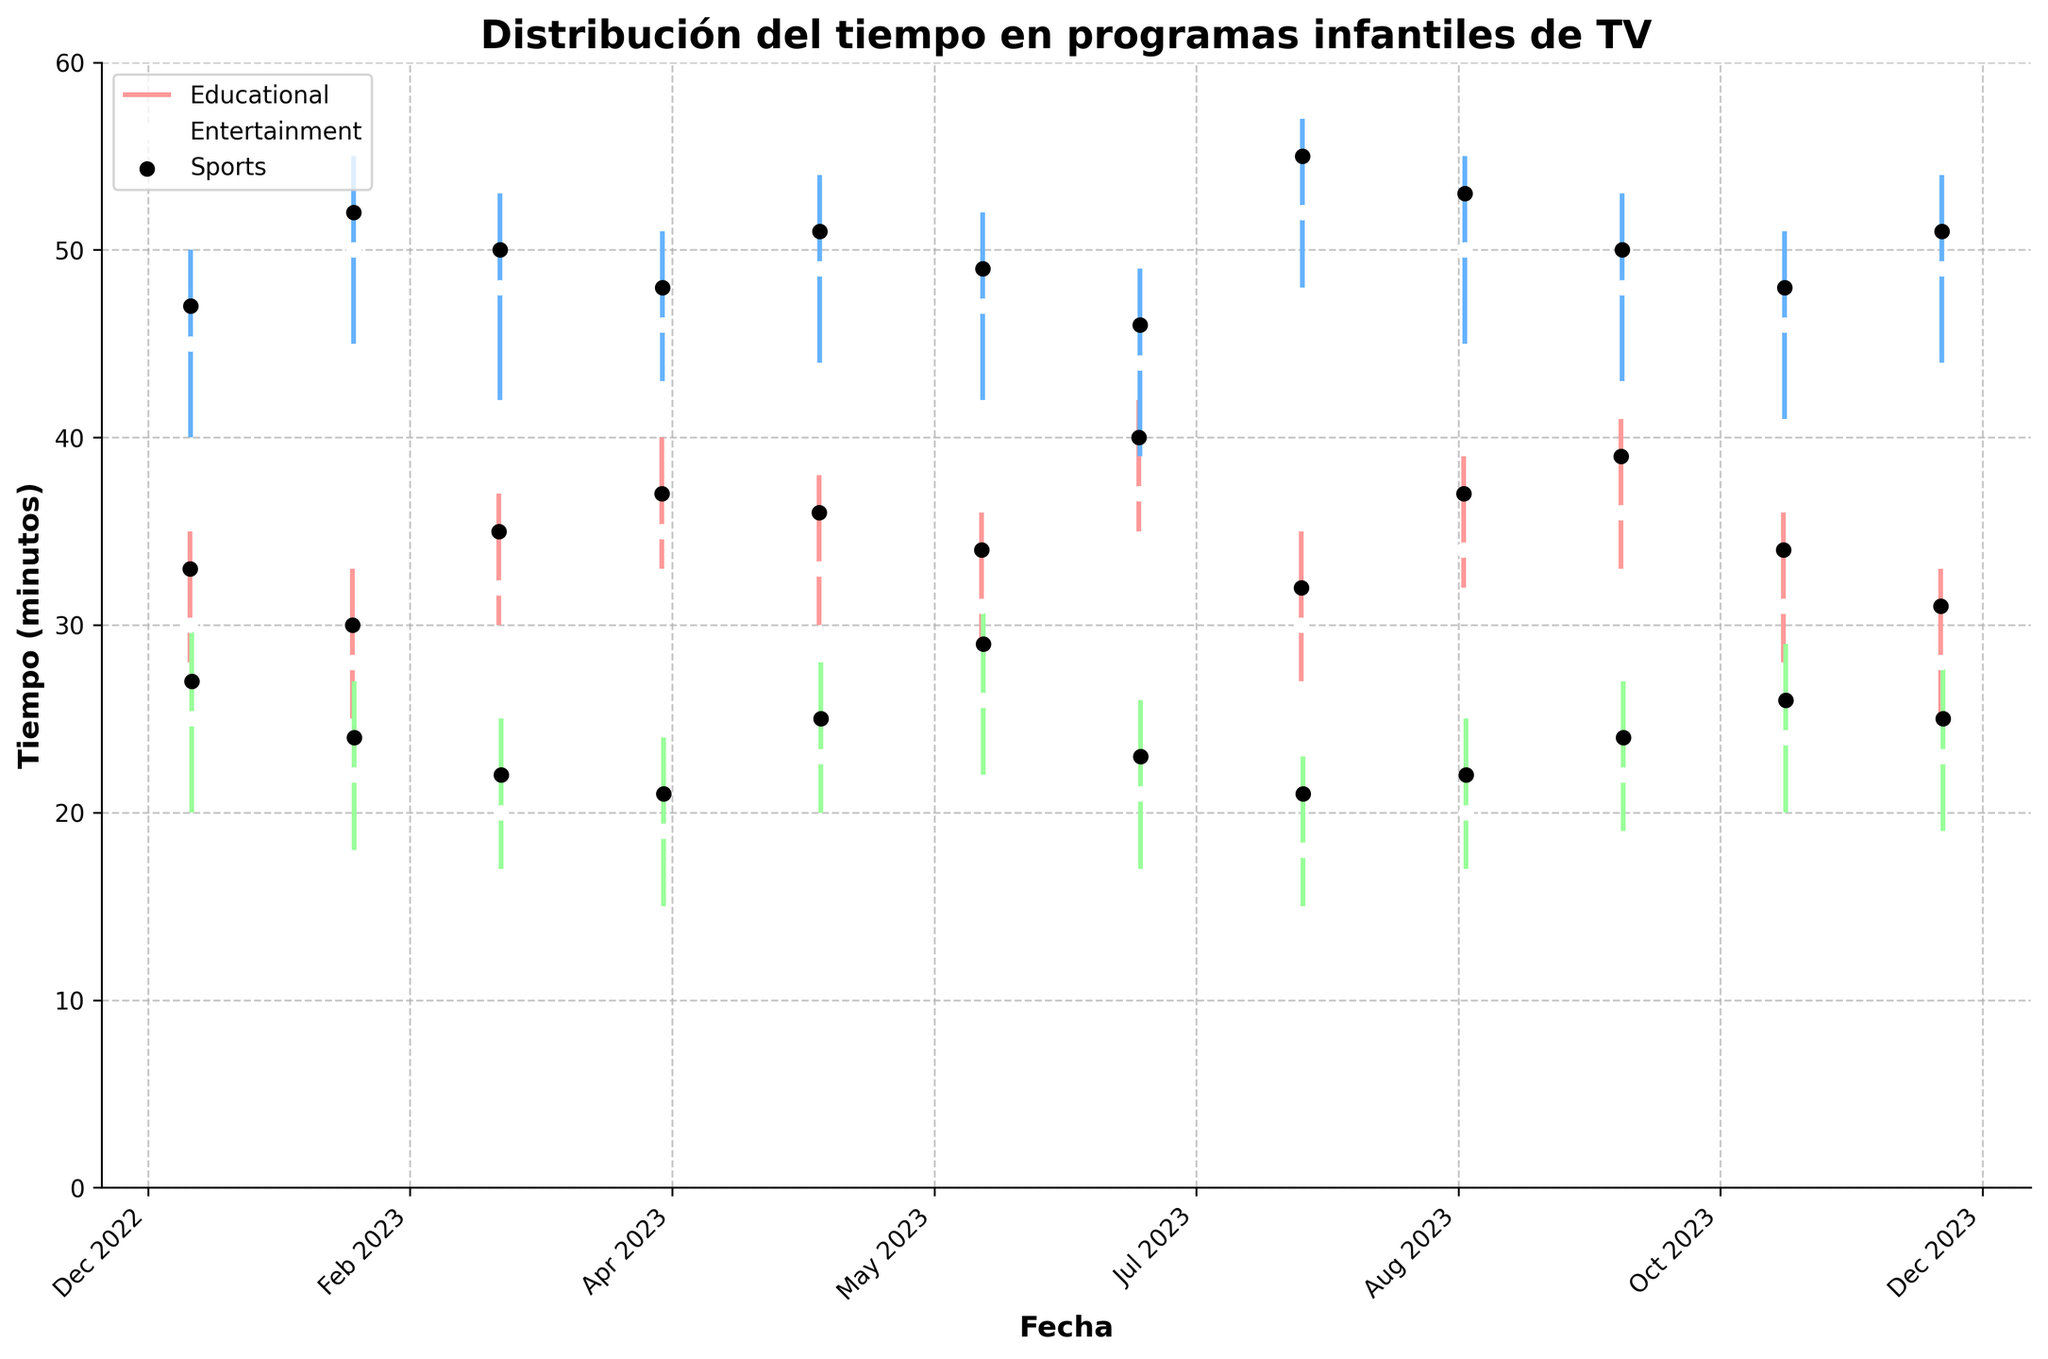What's the title of the figure? The title of the figure is displayed at the top of the plot.
Answer: Distribución del tiempo en programas infantiles de TV What are the three categories represented in the figure? The categories are listed in the legend and are also visible in the x-axis labels.
Answer: Educational, Entertainment, Sports What time period does the figure cover? The x-axis shows dates from January 2023 to December 2023.
Answer: January 2023 to December 2023 Which category had the highest time spent in August 2023? The black dots represent the closing value; in August 2023, the highest closing value is in the Entertainment category.
Answer: Entertainment What was the range of time spent on sports programs in March 2023? The vertical candlestick line for Sports in March 2023 shows the range. The high is 25 and the low is 17.
Answer: 8 minutes Which category had the most variability in time spent throughout the year? By looking at the length of the candlesticks, Entertainment shows the most variability with larger ranges.
Answer: Entertainment In which month did educational programs have the lowest closing value? The black dots represent closing values; for Educational, the lowest value is in December 2023 at 31 minutes.
Answer: December 2023 How many months did sports programs have a closing value above 25 minutes? By identifying the months where the black dots for Sports are above 25, we can see this occurs in July 2023 only.
Answer: 1 month When did entertainment programs have the smallest difference between open and close times? The difference between the white and black dots (open and close values) is smallest when they are close together; this occurs in January 2023.
Answer: January 2023 How does the open time for educational programs in January 2023 compare to December 2023? The open values for January 2023 (30 minutes) and December 2023 (28 minutes) show that January's open value is higher.
Answer: January is higher 